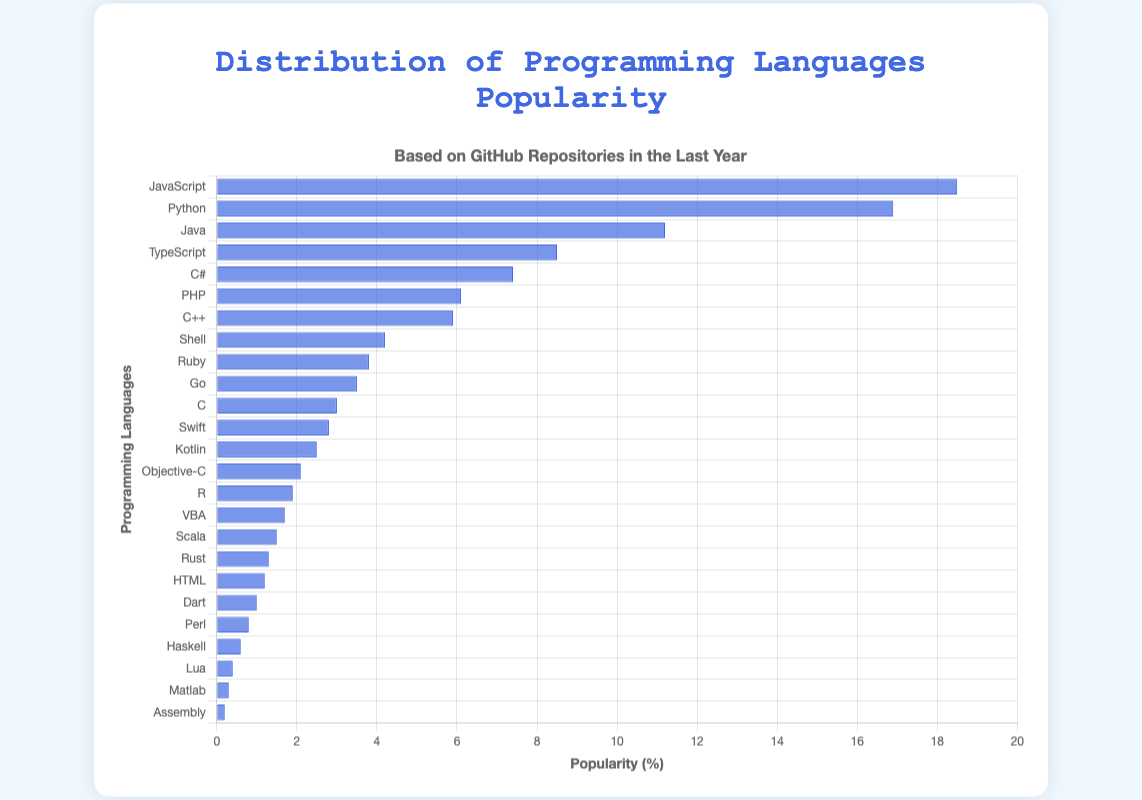Which programming language is the most popular? The tallest bar in the bar chart represents the most popular programming language. The bar for JavaScript is the tallest.
Answer: JavaScript How does Python's popularity compare to JavaScript's? JavaScript has a popularity of 18.5%, while Python has a popularity of 16.9%. We compare these values directly.
Answer: JavaScript is more popular What is the combined popularity of TypeScript and C#? TypeScript's popularity is 8.5%, and C#'s is 7.4%. Add these together to get the combined popularity: 8.5 + 7.4 = 15.9%
Answer: 15.9% What is the difference in popularity between Java and PHP? Java's popularity is 11.2%, and PHP's is 6.1%. Subtract PHP's popularity from Java's: 11.2 - 6.1 = 5.1%
Answer: 5.1% Which language has approximately half the popularity of Python? Python's popularity is 16.9%. Half of 16.9 is approximately 8.45. Check the languages around this value. TypeScript has a popularity of 8.5%.
Answer: TypeScript Which language has the least popularity? The shortest bar represents the least popular programming language. The bar for Assembly is the shortest, indicating a popularity of 0.2%.
Answer: Assembly What is the average popularity of Ruby, Go, and Swift? The popularities are Ruby: 3.8%, Go: 3.5%, and Swift: 2.8%. Sum these values and divide by 3: (3.8 + 3.5 + 2.8) / 3 = 3.37%
Answer: 3.37% Which language has a higher popularity, R or Kotlin? R has a popularity of 1.9%, and Kotlin has a popularity of 2.5%. Compare these values directly.
Answer: Kotlin What is the total popularity of the three least popular languages? The three least popular languages are Assembly (0.2%), Matlab (0.3%), and Lua (0.4%). Sum these values: 0.2 + 0.3 + 0.4 = 0.9%
Answer: 0.9% How does the popularity of Shell compare to that of Ruby? Shell has a popularity of 4.2%, and Ruby has a popularity of 3.8%. Compare these values directly.
Answer: Shell is more popular 